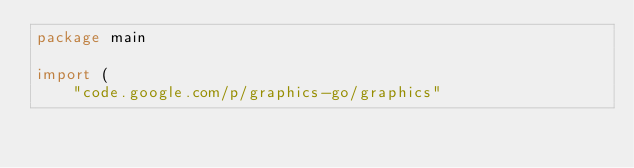<code> <loc_0><loc_0><loc_500><loc_500><_Go_>package main

import (
	"code.google.com/p/graphics-go/graphics"</code> 